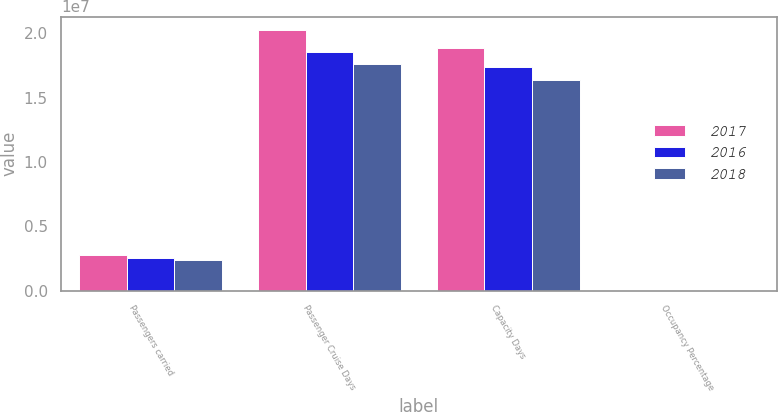<chart> <loc_0><loc_0><loc_500><loc_500><stacked_bar_chart><ecel><fcel>Passengers carried<fcel>Passenger Cruise Days<fcel>Capacity Days<fcel>Occupancy Percentage<nl><fcel>2017<fcel>2.7951e+06<fcel>2.02766e+07<fcel>1.88417e+07<fcel>107.6<nl><fcel>2016<fcel>2.51932e+06<fcel>1.8523e+07<fcel>1.73634e+07<fcel>106.7<nl><fcel>2018<fcel>2.33731e+06<fcel>1.75887e+07<fcel>1.63761e+07<fcel>107.4<nl></chart> 